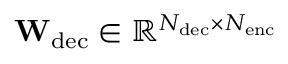<formula> <loc_0><loc_0><loc_500><loc_500>W _ { d e c } \in \mathbb { R } ^ { N _ { d e c } \times N _ { e n c } }</formula> 